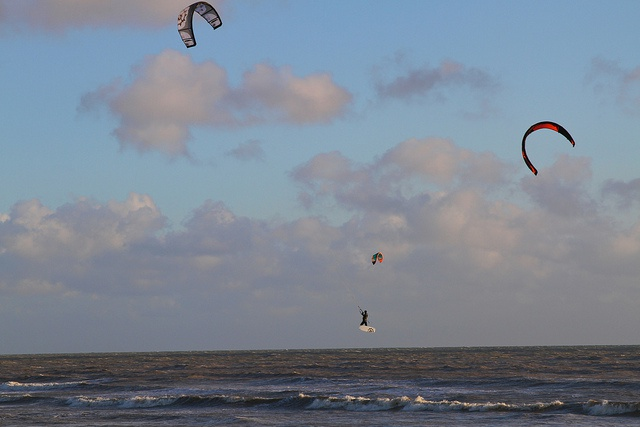Describe the objects in this image and their specific colors. I can see kite in gray, black, and darkgray tones, kite in gray, black, maroon, and red tones, kite in gray, black, teal, and brown tones, surfboard in gray, darkgray, and tan tones, and people in gray and black tones in this image. 